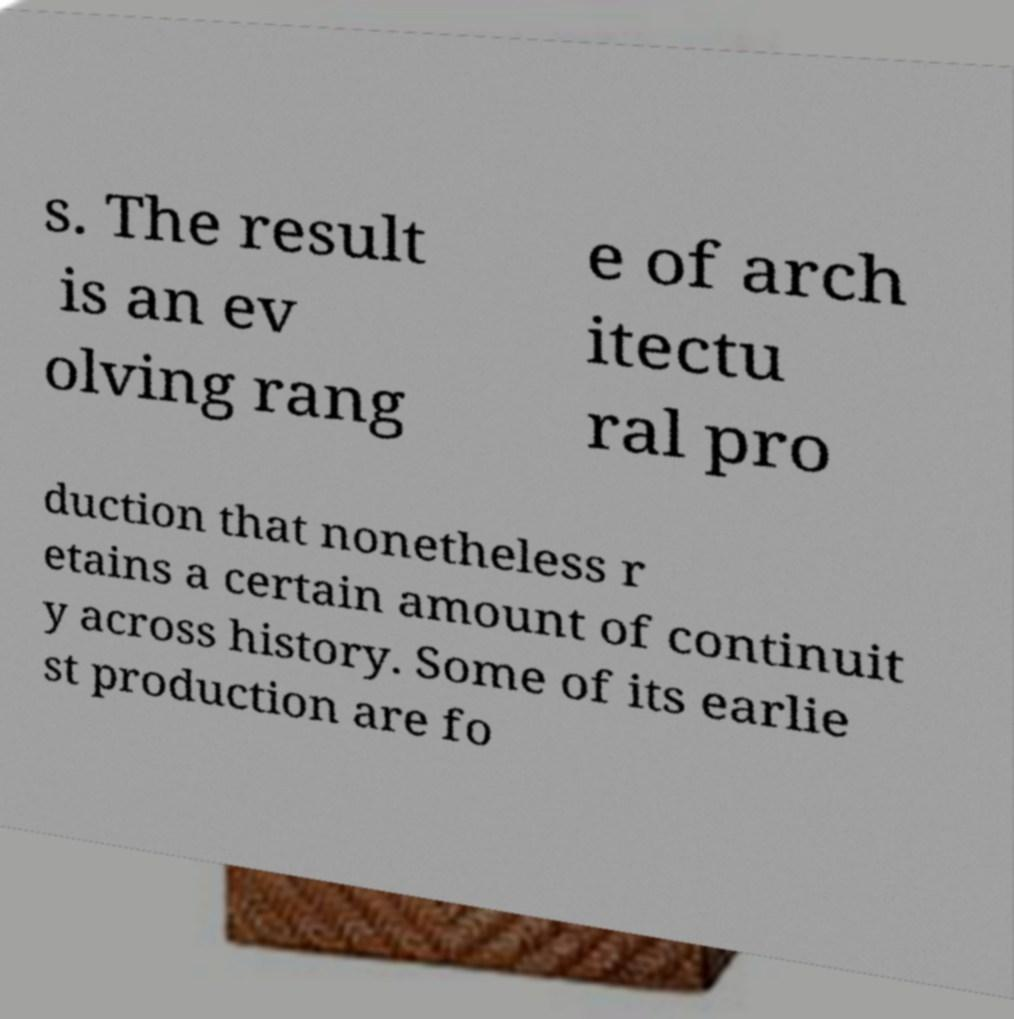Please read and relay the text visible in this image. What does it say? s. The result is an ev olving rang e of arch itectu ral pro duction that nonetheless r etains a certain amount of continuit y across history. Some of its earlie st production are fo 